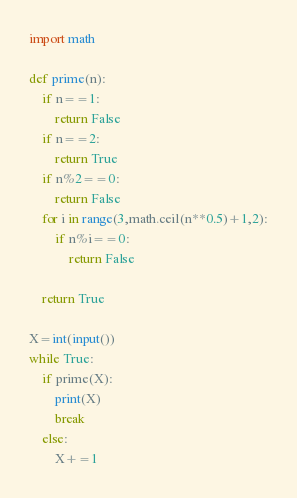<code> <loc_0><loc_0><loc_500><loc_500><_Python_>import math

def prime(n):
    if n==1:
        return False
    if n==2:
        return True
    if n%2==0:
        return False
    for i in range(3,math.ceil(n**0.5)+1,2):
        if n%i==0:
            return False
    
    return True

X=int(input())
while True:
    if prime(X):
        print(X)
        break
    else:
        X+=1</code> 